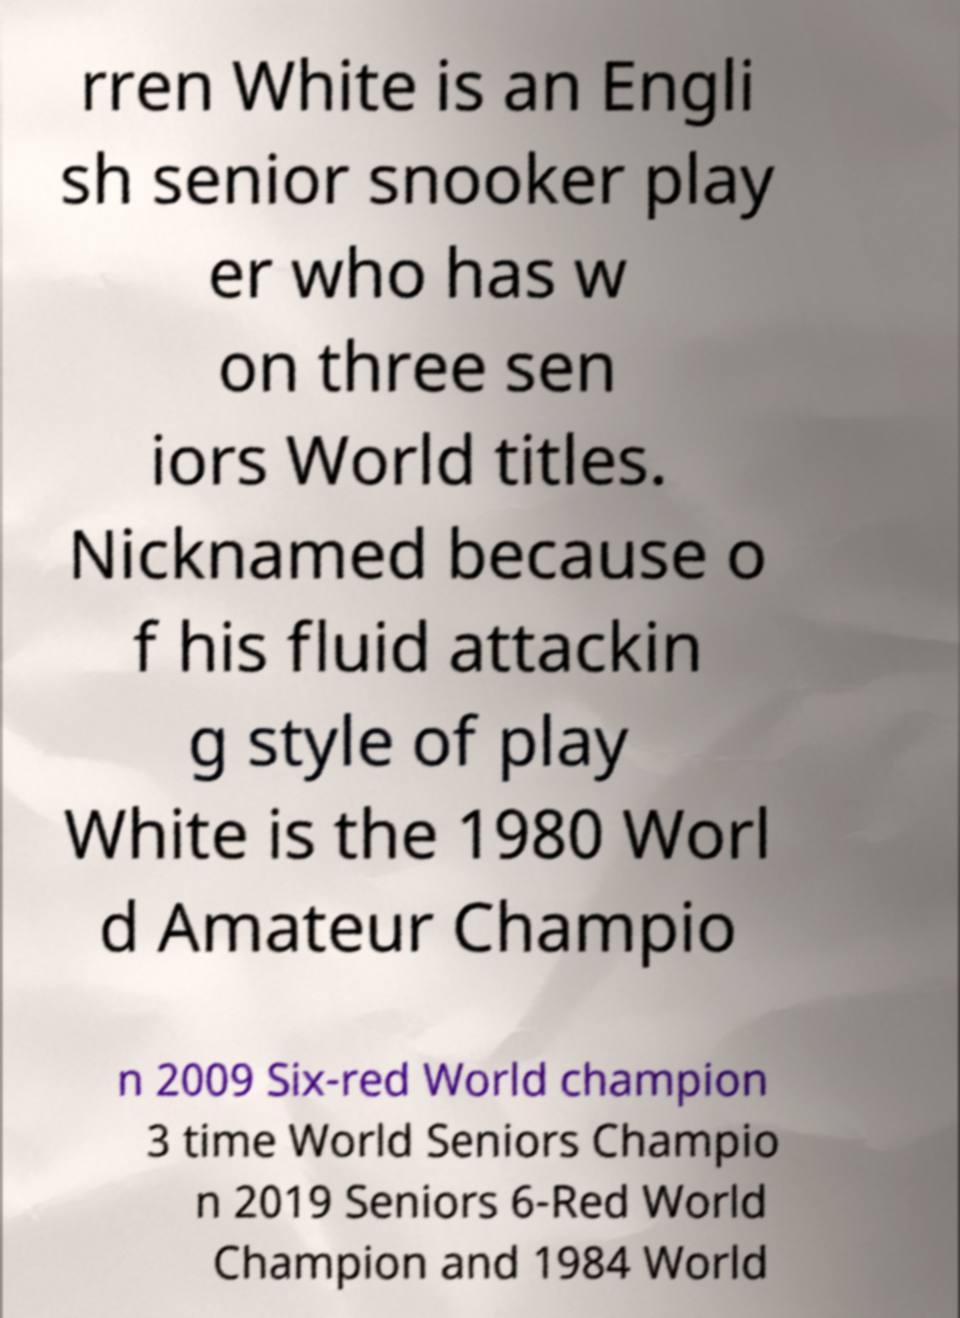Could you assist in decoding the text presented in this image and type it out clearly? rren White is an Engli sh senior snooker play er who has w on three sen iors World titles. Nicknamed because o f his fluid attackin g style of play White is the 1980 Worl d Amateur Champio n 2009 Six-red World champion 3 time World Seniors Champio n 2019 Seniors 6-Red World Champion and 1984 World 